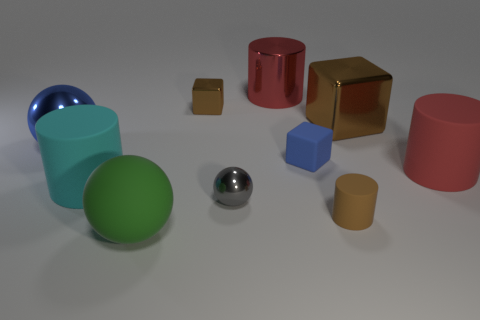How many tiny things are cyan objects or blue cubes?
Your answer should be compact. 1. There is a blue matte cube; is its size the same as the matte cylinder that is left of the green matte ball?
Keep it short and to the point. No. Are there any other things that have the same shape as the gray metallic thing?
Ensure brevity in your answer.  Yes. What number of big rubber spheres are there?
Your answer should be very brief. 1. What number of red objects are balls or large spheres?
Provide a succinct answer. 0. Does the brown thing that is in front of the blue metal ball have the same material as the big green sphere?
Give a very brief answer. Yes. What number of other things are made of the same material as the big cyan object?
Your answer should be very brief. 4. What is the material of the large cyan thing?
Your answer should be compact. Rubber. There is a block that is in front of the blue metallic sphere; how big is it?
Offer a terse response. Small. What number of blue rubber objects are on the left side of the big red cylinder that is left of the tiny blue rubber thing?
Your response must be concise. 0. 